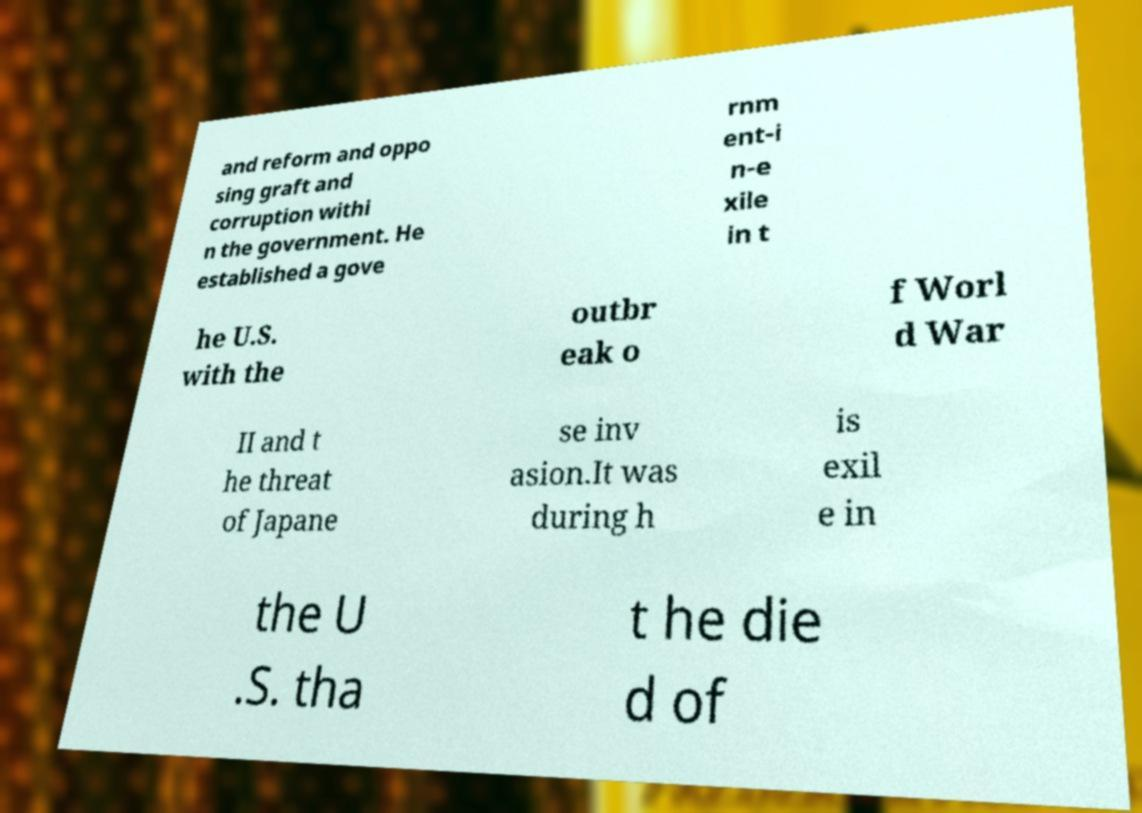Please read and relay the text visible in this image. What does it say? and reform and oppo sing graft and corruption withi n the government. He established a gove rnm ent-i n-e xile in t he U.S. with the outbr eak o f Worl d War II and t he threat of Japane se inv asion.It was during h is exil e in the U .S. tha t he die d of 